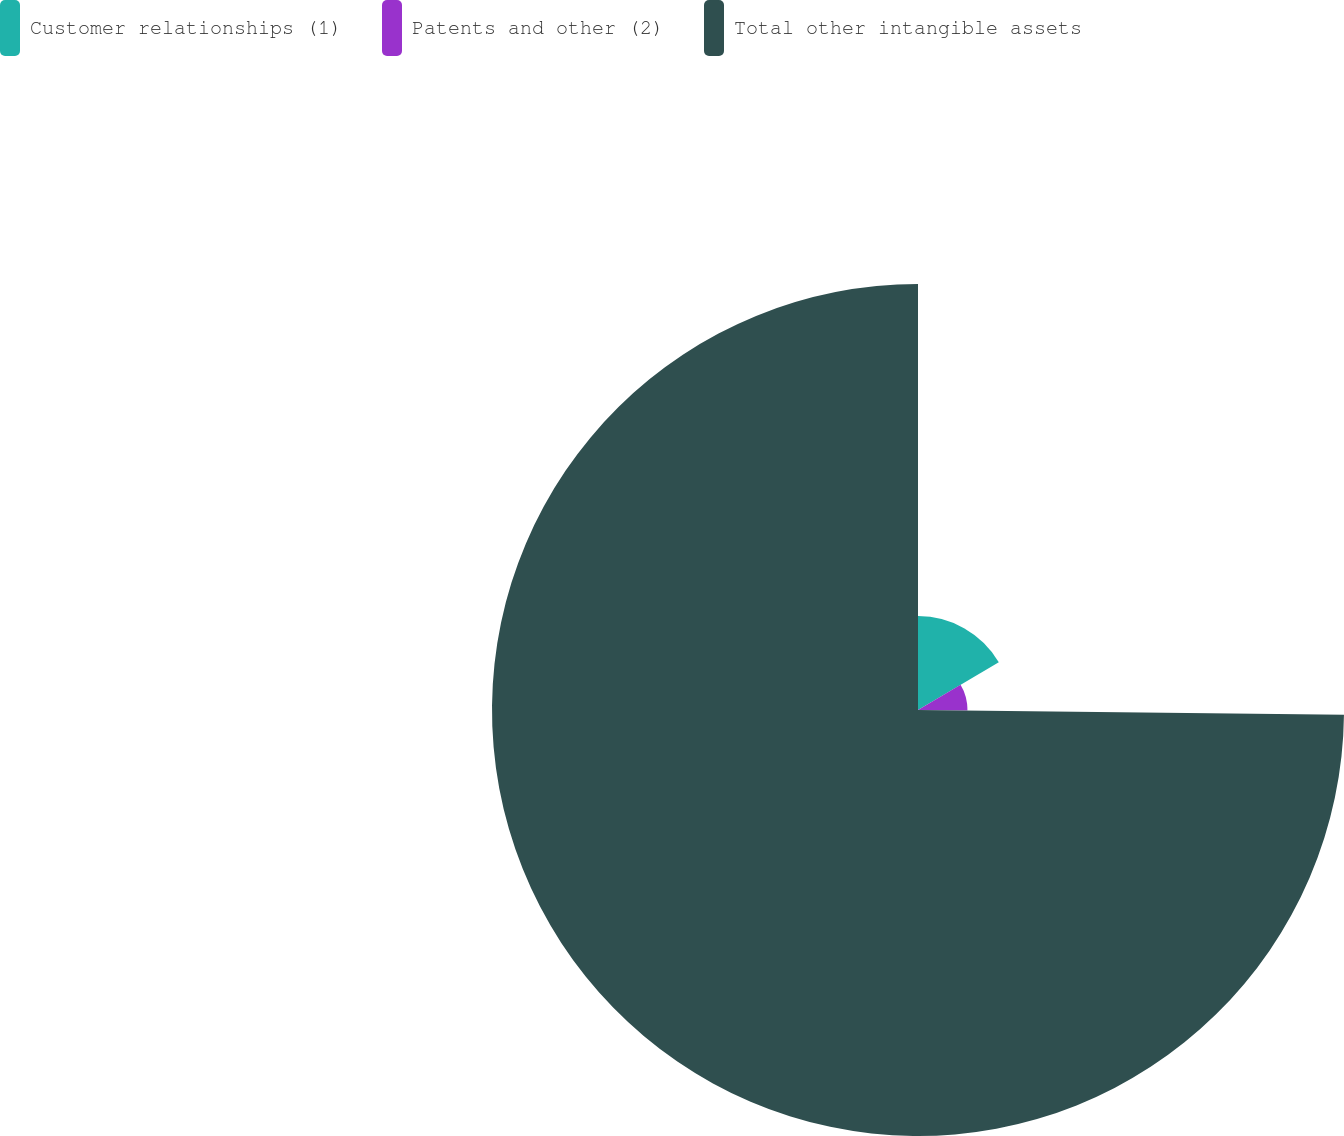Convert chart to OTSL. <chart><loc_0><loc_0><loc_500><loc_500><pie_chart><fcel>Customer relationships (1)<fcel>Patents and other (2)<fcel>Total other intangible assets<nl><fcel>16.49%<fcel>8.69%<fcel>74.82%<nl></chart> 